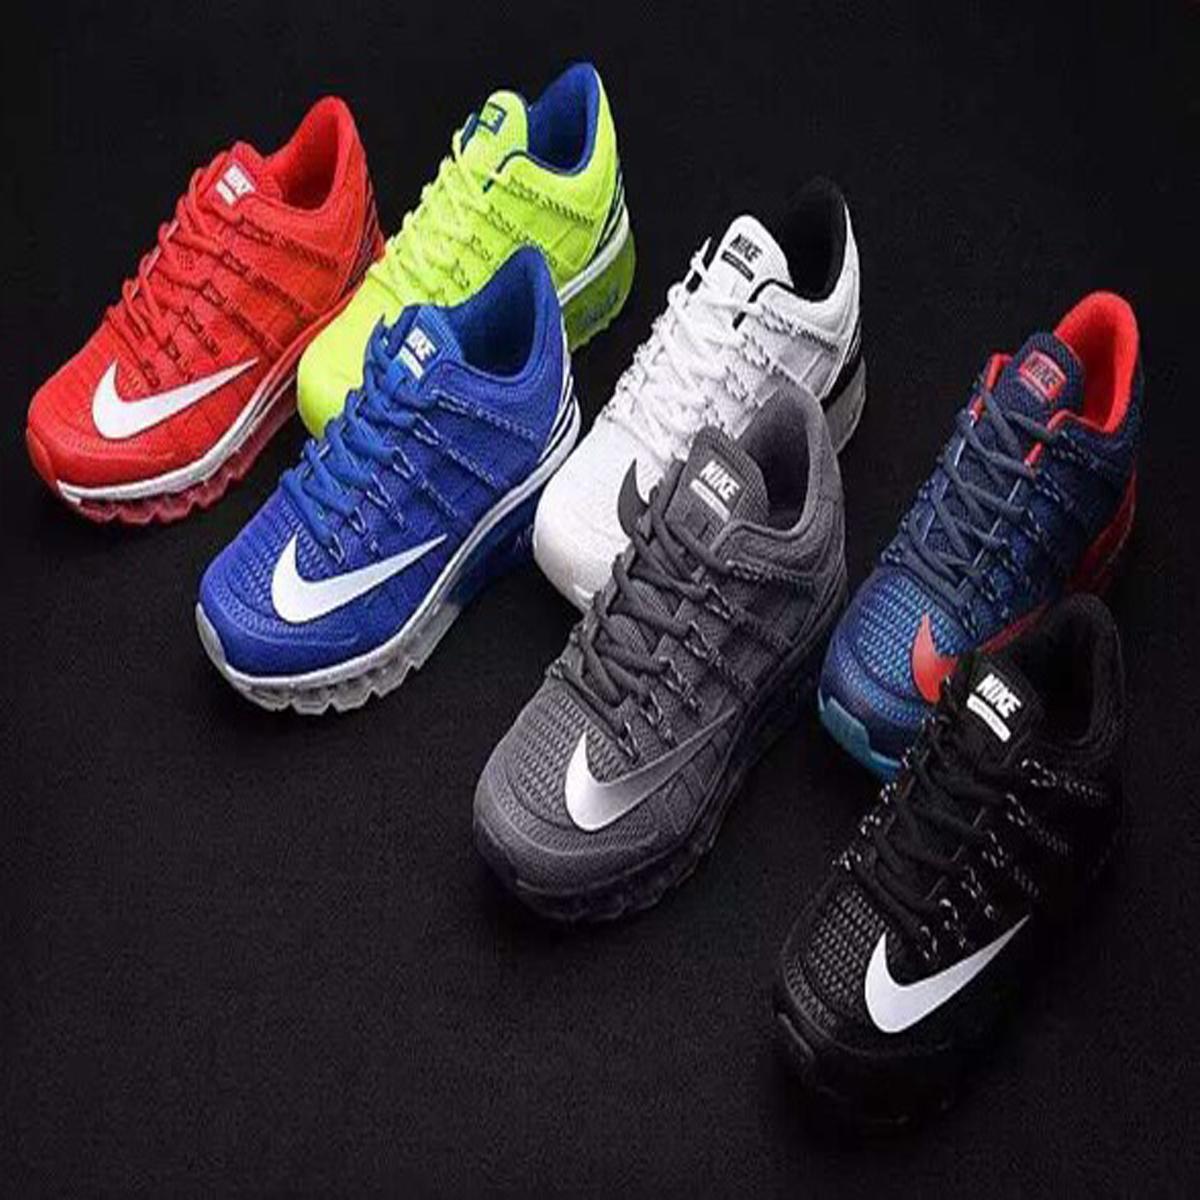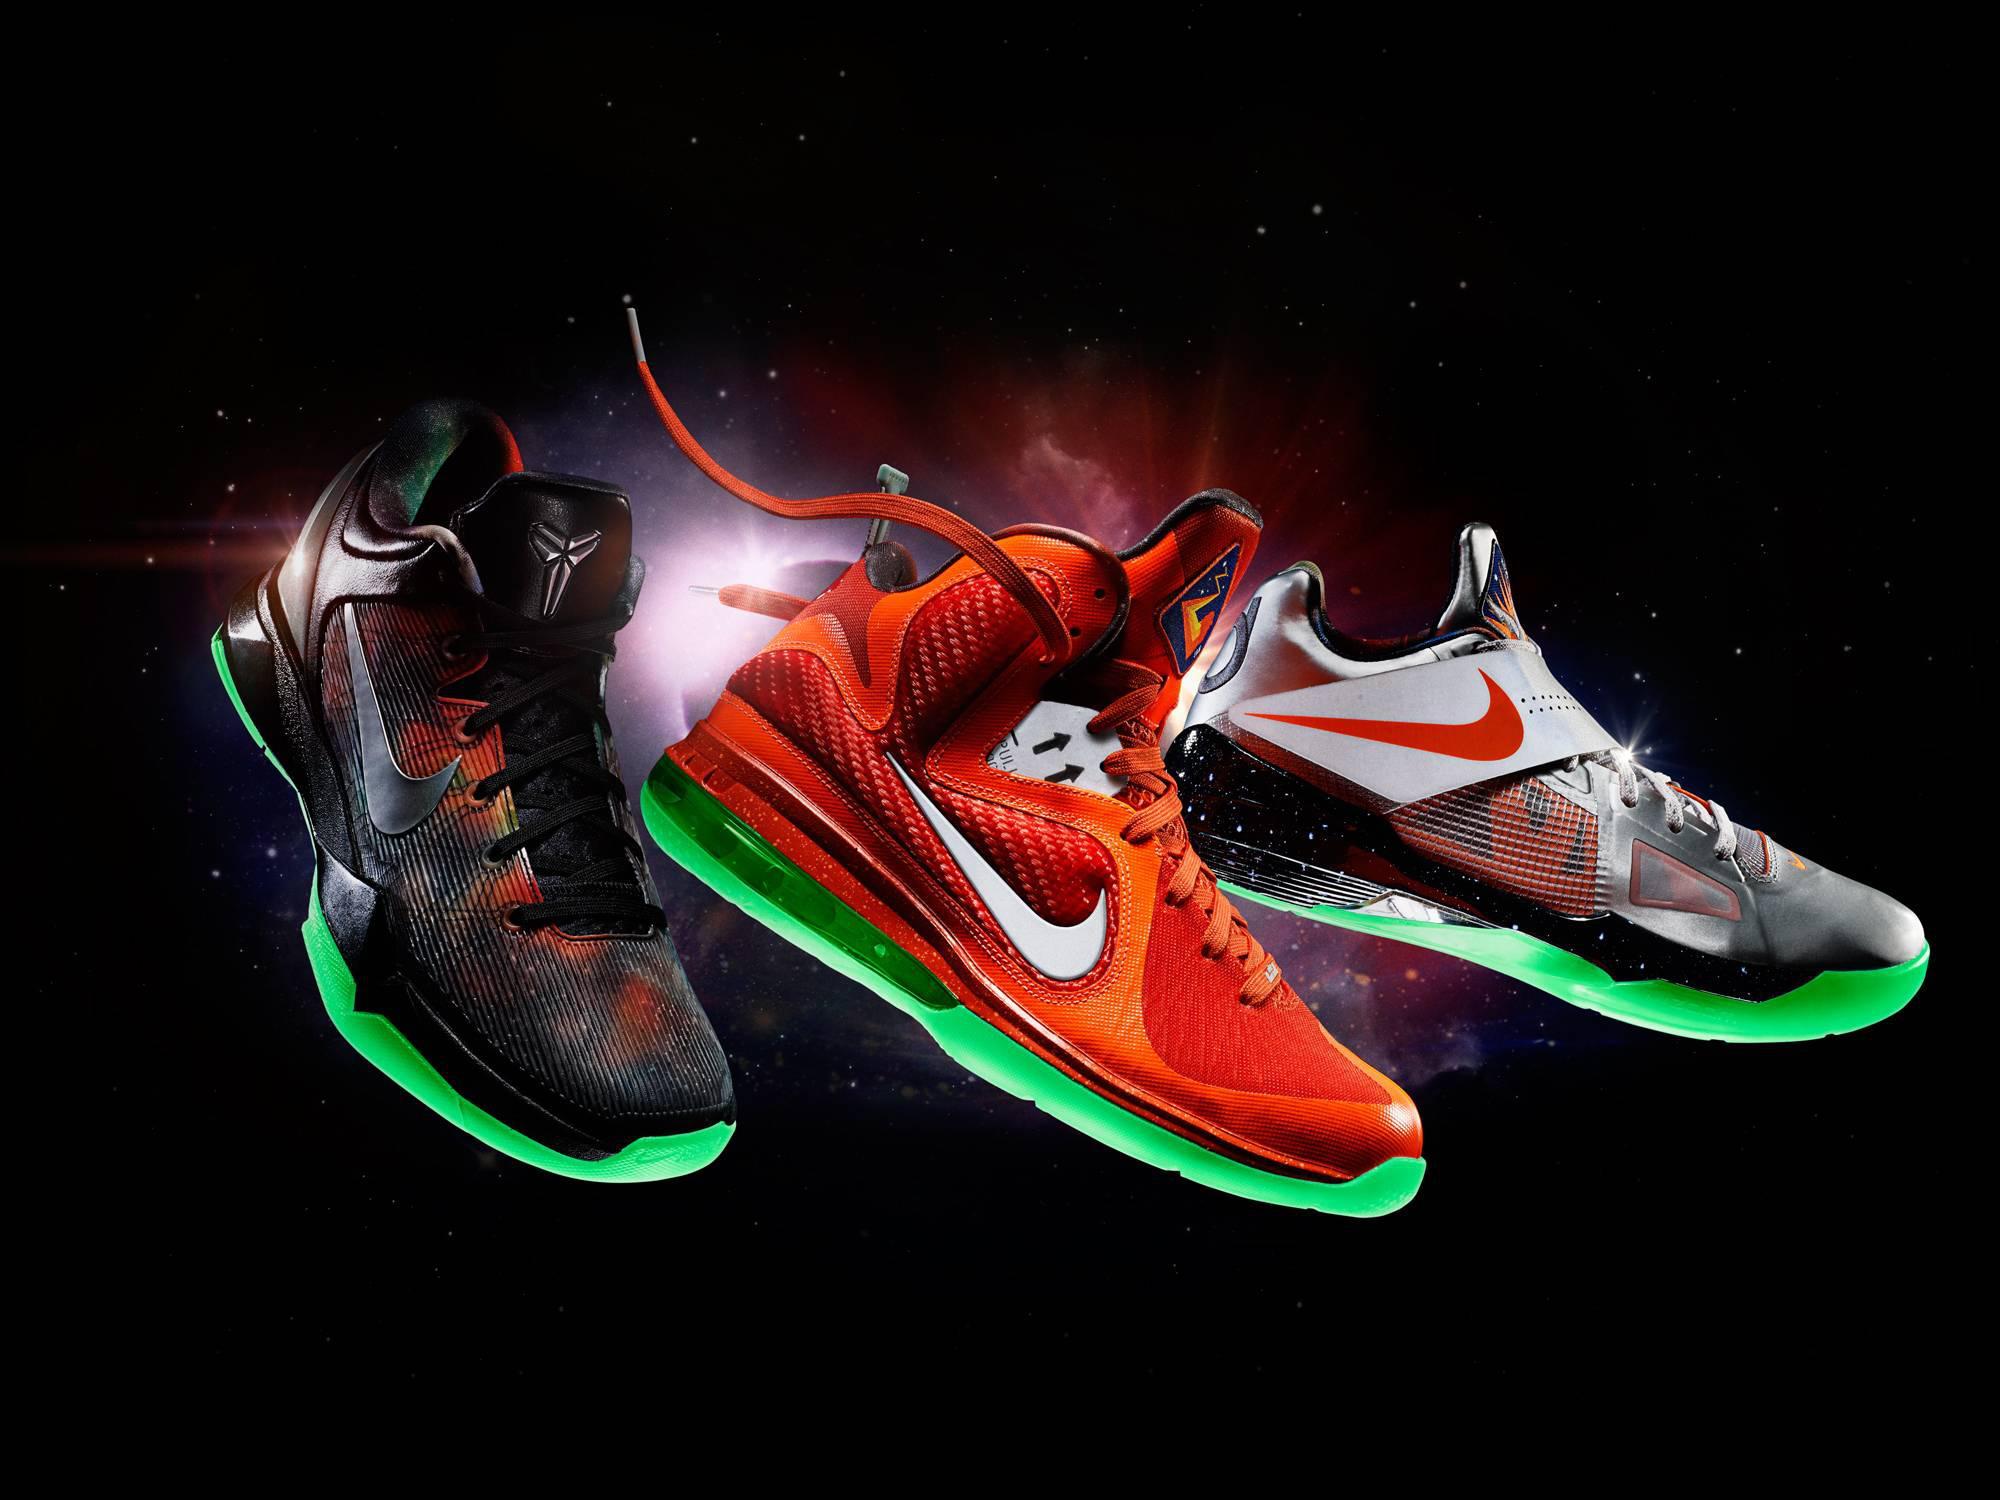The first image is the image on the left, the second image is the image on the right. Assess this claim about the two images: "The left image contains at least five shoes.". Correct or not? Answer yes or no. Yes. The first image is the image on the left, the second image is the image on the right. Examine the images to the left and right. Is the description "One image contains one pair of new shoes, and the other image contains at least eight shoes and includes pairs." accurate? Answer yes or no. No. 